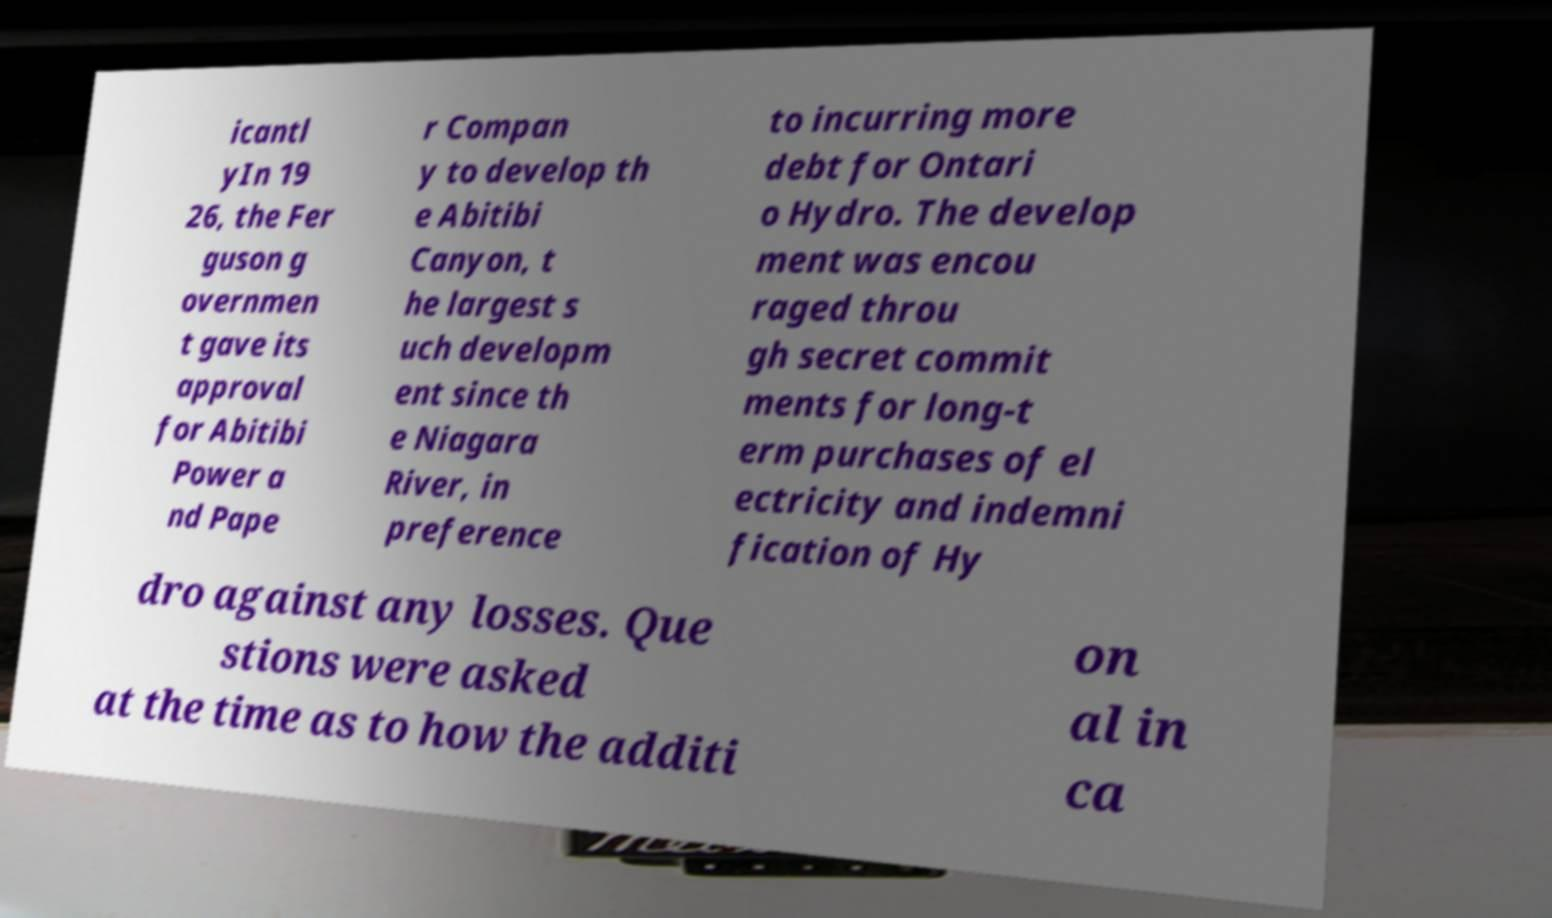Could you extract and type out the text from this image? icantl yIn 19 26, the Fer guson g overnmen t gave its approval for Abitibi Power a nd Pape r Compan y to develop th e Abitibi Canyon, t he largest s uch developm ent since th e Niagara River, in preference to incurring more debt for Ontari o Hydro. The develop ment was encou raged throu gh secret commit ments for long-t erm purchases of el ectricity and indemni fication of Hy dro against any losses. Que stions were asked at the time as to how the additi on al in ca 